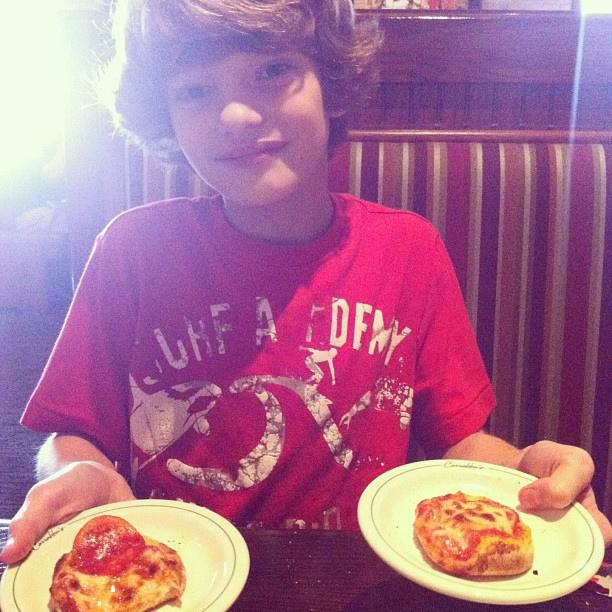Why is the one on the right missing a pepperoni?
Be succinct. Already eaten. Is this a boy or girl?
Be succinct. Boy. What color is the boys shirt?
Concise answer only. Red. 